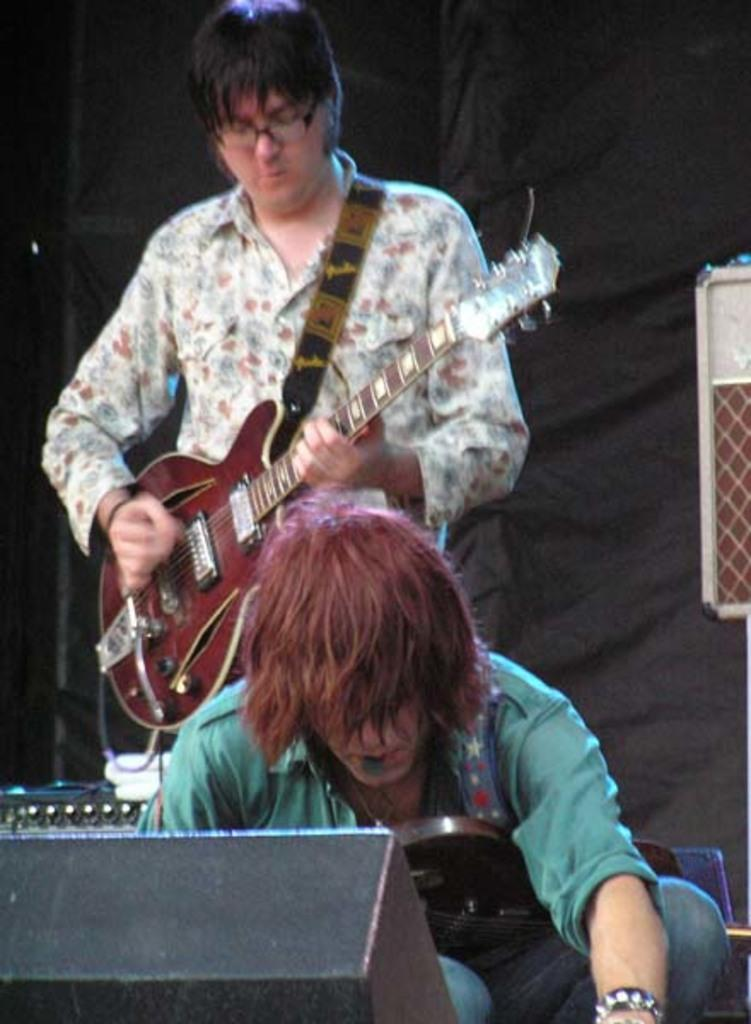How many people are in the image? There are two persons in the image. What is one of the persons doing? One of the persons is playing a guitar. What else can be seen in the image besides the people? There are devices and an object in the image. Can you describe the background of the image? The background of the image is dark. What type of food is being prepared on the curtain in the image? There is no curtain or food preparation visible in the image. How many oranges are on the table in the image? There are no oranges present in the image. 